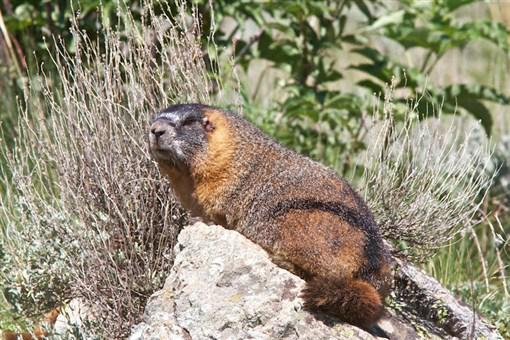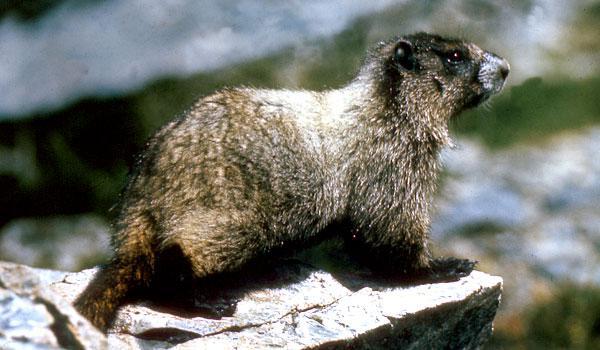The first image is the image on the left, the second image is the image on the right. Evaluate the accuracy of this statement regarding the images: "There is signal tan and brown animal sitting on a rock looking left.". Is it true? Answer yes or no. Yes. The first image is the image on the left, the second image is the image on the right. Assess this claim about the two images: "At least one of the animals is standing up on its hind legs.". Correct or not? Answer yes or no. No. The first image is the image on the left, the second image is the image on the right. Analyze the images presented: Is the assertion "Right image shows a rightward-facing marmot perched on a rock with its tail visible." valid? Answer yes or no. Yes. The first image is the image on the left, the second image is the image on the right. For the images displayed, is the sentence "There are only two animals, and they are facing opposite directions." factually correct? Answer yes or no. Yes. 